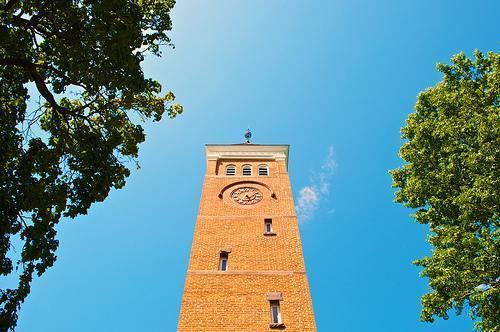How many clocks are there?
Give a very brief answer. 1. 